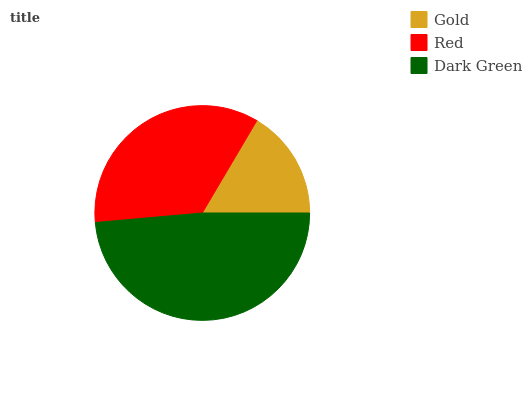Is Gold the minimum?
Answer yes or no. Yes. Is Dark Green the maximum?
Answer yes or no. Yes. Is Red the minimum?
Answer yes or no. No. Is Red the maximum?
Answer yes or no. No. Is Red greater than Gold?
Answer yes or no. Yes. Is Gold less than Red?
Answer yes or no. Yes. Is Gold greater than Red?
Answer yes or no. No. Is Red less than Gold?
Answer yes or no. No. Is Red the high median?
Answer yes or no. Yes. Is Red the low median?
Answer yes or no. Yes. Is Gold the high median?
Answer yes or no. No. Is Dark Green the low median?
Answer yes or no. No. 